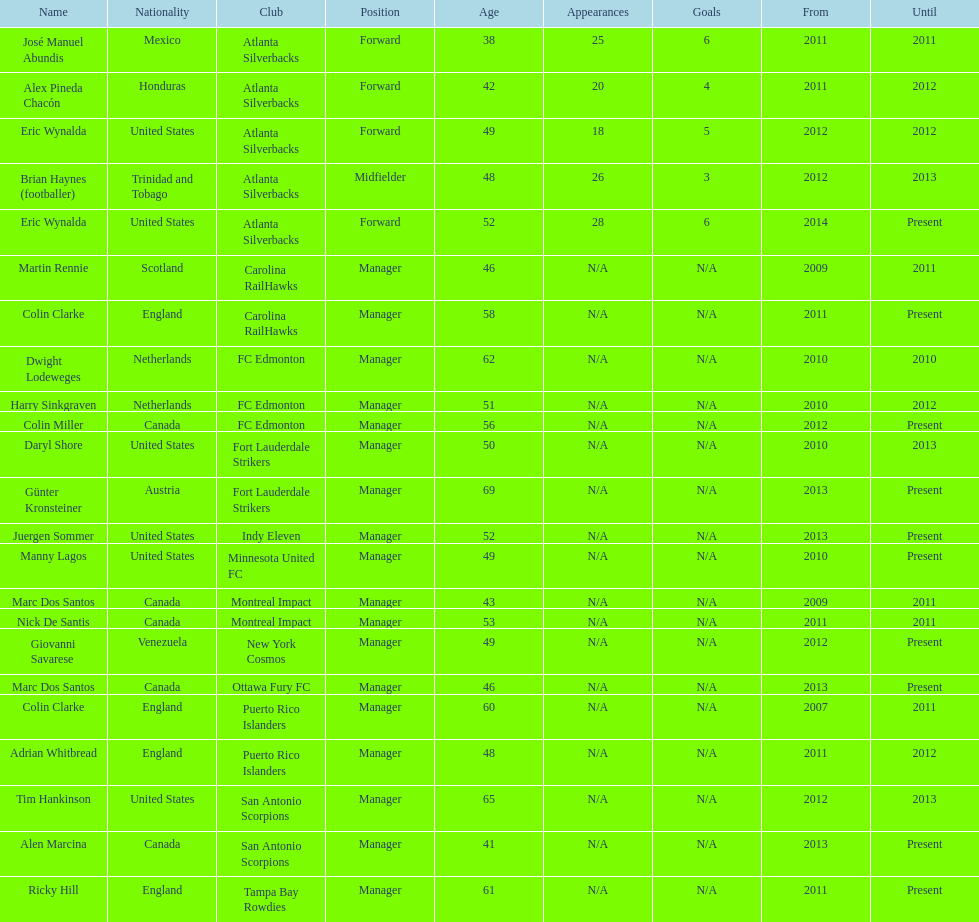Could you help me parse every detail presented in this table? {'header': ['Name', 'Nationality', 'Club', 'Position', 'Age', 'Appearances', 'Goals', 'From', 'Until'], 'rows': [['José Manuel Abundis', 'Mexico', 'Atlanta Silverbacks', 'Forward', '38', '25', '6', '2011', '2011'], ['Alex Pineda Chacón', 'Honduras', 'Atlanta Silverbacks', 'Forward', '42', '20', '4', '2011', '2012'], ['Eric Wynalda', 'United States', 'Atlanta Silverbacks', 'Forward', '49', '18', '5', '2012', '2012'], ['Brian Haynes (footballer)', 'Trinidad and Tobago', 'Atlanta Silverbacks', 'Midfielder', '48', '26', '3', '2012', '2013'], ['Eric Wynalda', 'United States', 'Atlanta Silverbacks', 'Forward', '52', '28', '6', '2014', 'Present'], ['Martin Rennie', 'Scotland', 'Carolina RailHawks', 'Manager', '46', 'N/A', 'N/A', '2009', '2011'], ['Colin Clarke', 'England', 'Carolina RailHawks', 'Manager', '58', 'N/A', 'N/A', '2011', 'Present'], ['Dwight Lodeweges', 'Netherlands', 'FC Edmonton', 'Manager', '62', 'N/A', 'N/A', '2010', '2010'], ['Harry Sinkgraven', 'Netherlands', 'FC Edmonton', 'Manager', '51', 'N/A', 'N/A', '2010', '2012'], ['Colin Miller', 'Canada', 'FC Edmonton', 'Manager', '56', 'N/A', 'N/A', '2012', 'Present'], ['Daryl Shore', 'United States', 'Fort Lauderdale Strikers', 'Manager', '50', 'N/A', 'N/A', '2010', '2013'], ['Günter Kronsteiner', 'Austria', 'Fort Lauderdale Strikers', 'Manager', '69', 'N/A', 'N/A', '2013', 'Present'], ['Juergen Sommer', 'United States', 'Indy Eleven', 'Manager', '52', 'N/A', 'N/A', '2013', 'Present'], ['Manny Lagos', 'United States', 'Minnesota United FC', 'Manager', '49', 'N/A', 'N/A', '2010', 'Present'], ['Marc Dos Santos', 'Canada', 'Montreal Impact', 'Manager', '43', 'N/A', 'N/A', '2009', '2011'], ['Nick De Santis', 'Canada', 'Montreal Impact', 'Manager', '53', 'N/A', 'N/A', '2011', '2011'], ['Giovanni Savarese', 'Venezuela', 'New York Cosmos', 'Manager', '49', 'N/A', 'N/A', '2012', 'Present'], ['Marc Dos Santos', 'Canada', 'Ottawa Fury FC', 'Manager', '46', 'N/A', 'N/A', '2013', 'Present'], ['Colin Clarke', 'England', 'Puerto Rico Islanders', 'Manager', '60', 'N/A', 'N/A', '2007', '2011'], ['Adrian Whitbread', 'England', 'Puerto Rico Islanders', 'Manager', '48', 'N/A', 'N/A', '2011', '2012'], ['Tim Hankinson', 'United States', 'San Antonio Scorpions', 'Manager', '65', 'N/A', 'N/A', '2012', '2013'], ['Alen Marcina', 'Canada', 'San Antonio Scorpions', 'Manager', '41', 'N/A', 'N/A', '2013', 'Present'], ['Ricky Hill', 'England', 'Tampa Bay Rowdies', 'Manager', '61', 'N/A', 'N/A', '2011', 'Present']]} How many total coaches on the list are from canada? 5. 